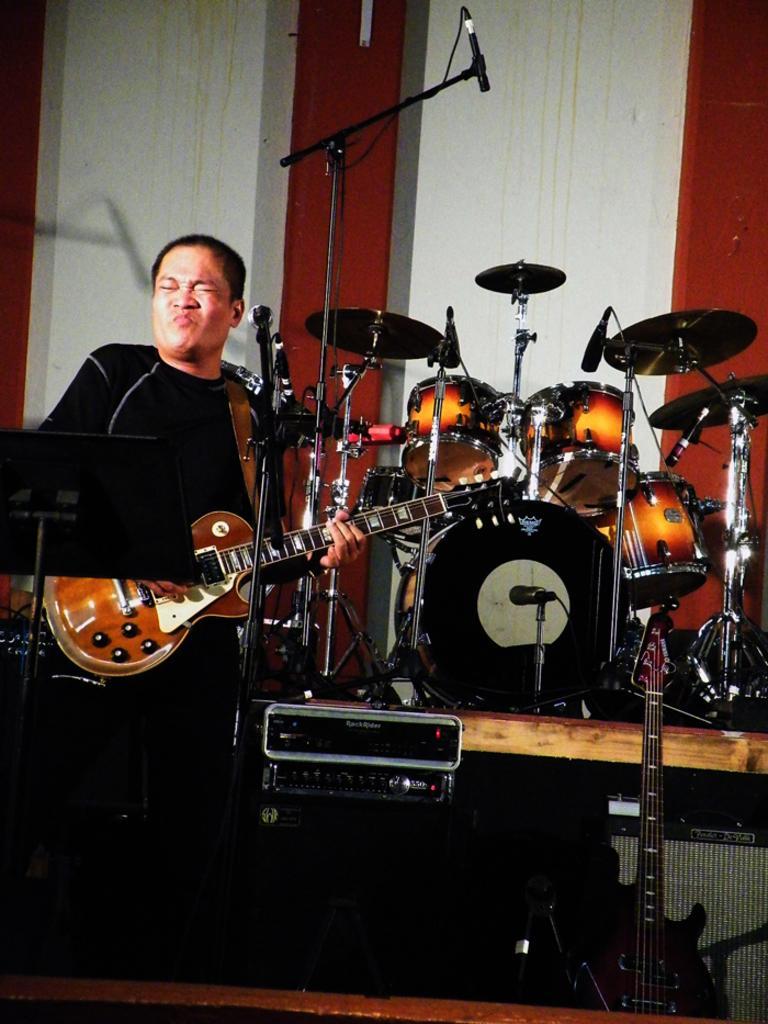Describe this image in one or two sentences. A man is playing guitar. In front of him there is a mic. Beside him there are few musical instruments. In the background there is a wall. 